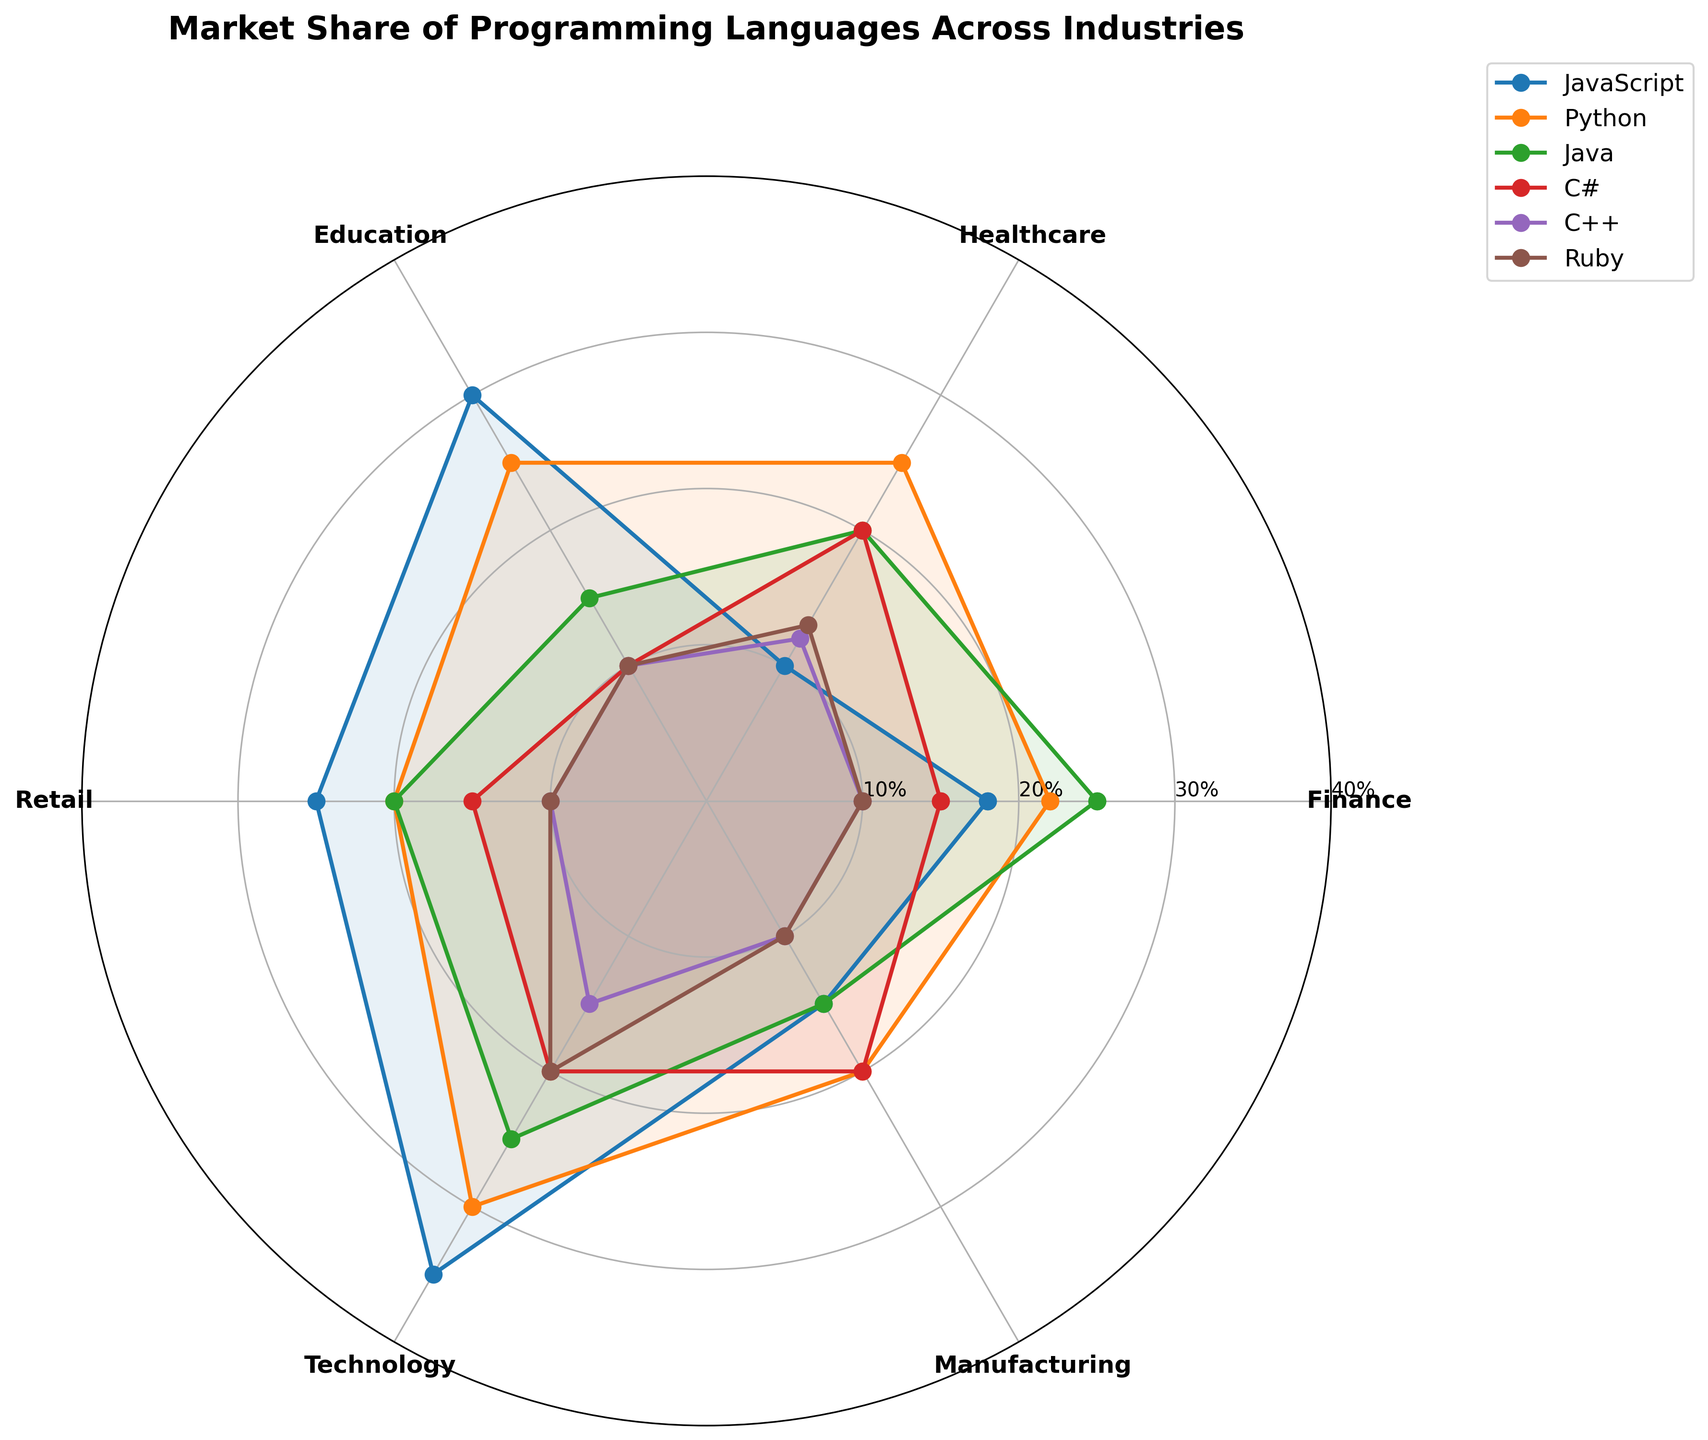What's the title of the polar chart? The title is displayed at the top center of the chart in a bold font: "Market Share of Programming Languages Across Industries."
Answer: "Market Share of Programming Languages Across Industries" Which programming language has the highest market share in the Technology sector? The Technology sector is marked on the polar plot, and the highest market share can be identified by the outermost data point labeled 'Technology.' JavaScript has the highest value.
Answer: JavaScript Which industry sector shows the lowest market share for C++? Locate the C++ ring in the polar plot and identify the sector with the shortest radial extension from the origin. The Finance sector has the lowest market share for C++.
Answer: Finance What is the average market share of Python across all industry sectors? Summing up Python's market share values (22+25+25+20+30+20) gives 142. Dividing by the number of sectors (6) results in an average of 23.67%.
Answer: 23.67% Is the market share of Java greater in the Technology or Retail sector? Compare the radial distance for Java in the Technology and Retail sectors. The Technology sector shows a greater radial distance, indicating a higher market share for Java.
Answer: Technology Which programming language has a consistently higher market share across the majority of the industry sectors: Java or C#? By comparing the radial lengths for Java and C# across all sectors, Java consistently has a longer radial distance in most sectors compared to C#.
Answer: Java Which industry sector has the most balanced market share distribution among all programming languages? Analyze the equal radial extensions from the center for each language within an industry sector. The Education sector has a comparable distribution for all programming languages.
Answer: Education What is the market share difference between JavaScript and Ruby in the Finance sector? Identify their radial lengths in the Finance sector and subtract Ruby's value from JavaScript's value (18 - 10) to find the market share difference.
Answer: 8% How many industry sectors have a market share of JavaScript exceeding 20%? Count the number of sectors where JavaScript's radial extension surpasses the 20% mark. JavaScript exceeds 20% in Technology (35), Retail (25), and Education (30).
Answer: 3 sectors Does any programming language have a 25% market share across more than one industry sector? Verify each language for the exact market share across sectors. Python has a 25% market share in Finance, Healthcare, and Education sectors.
Answer: Python 